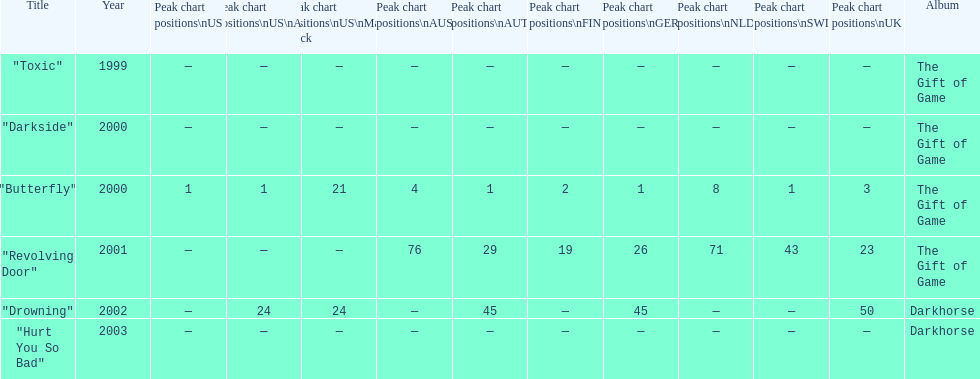How many singles have a ranking of 1 under ger? 1. 